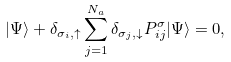<formula> <loc_0><loc_0><loc_500><loc_500>| \Psi \rangle + \delta _ { \sigma _ { i } , \uparrow } \sum _ { j = 1 } ^ { N _ { a } } \delta _ { \sigma _ { j } , \downarrow } P ^ { \sigma } _ { i j } | \Psi \rangle = 0 ,</formula> 